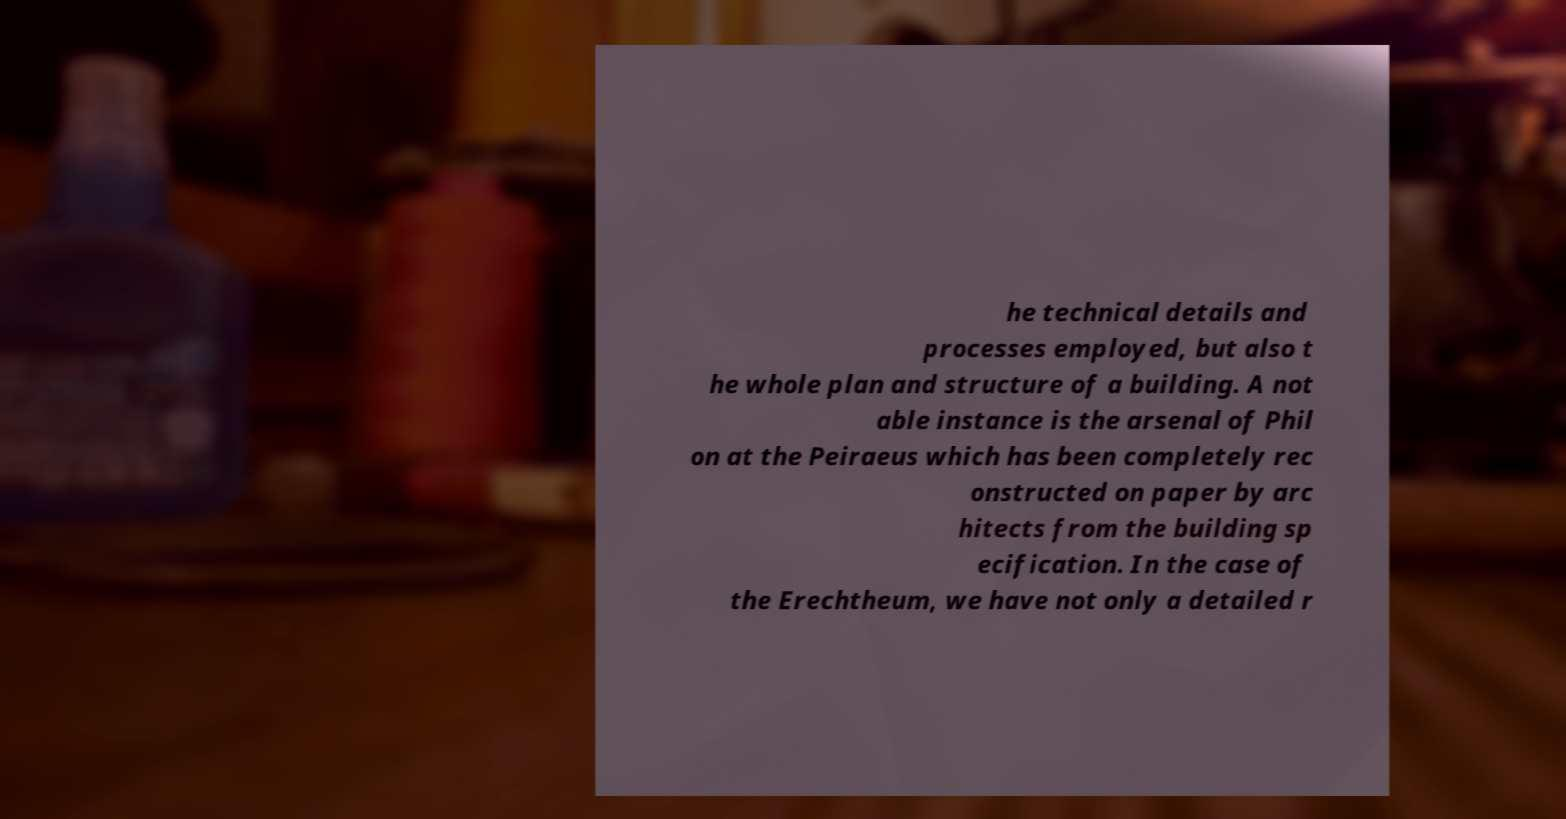Can you accurately transcribe the text from the provided image for me? he technical details and processes employed, but also t he whole plan and structure of a building. A not able instance is the arsenal of Phil on at the Peiraeus which has been completely rec onstructed on paper by arc hitects from the building sp ecification. In the case of the Erechtheum, we have not only a detailed r 